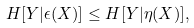Convert formula to latex. <formula><loc_0><loc_0><loc_500><loc_500>H [ Y | \epsilon ( X ) ] \leq H [ Y | \eta ( X ) ] ,</formula> 